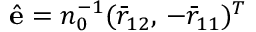<formula> <loc_0><loc_0><loc_500><loc_500>\hat { e } = n _ { 0 } ^ { - 1 } ( \bar { r } _ { 1 2 } , \, - \bar { r } _ { 1 1 } ) ^ { T }</formula> 